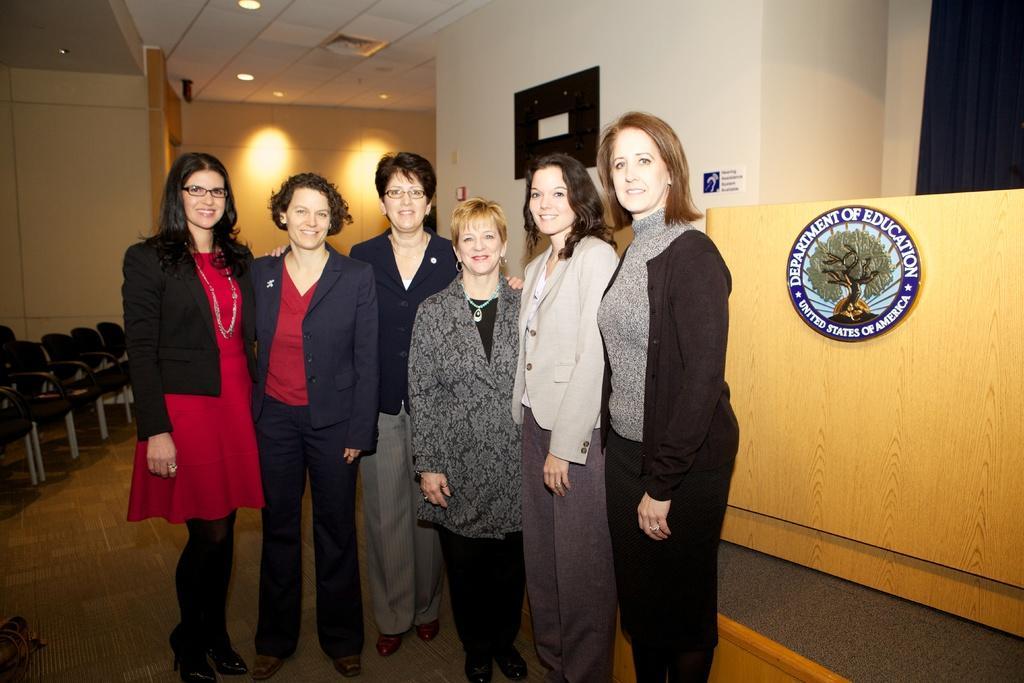Describe this image in one or two sentences. In this image we can see a group of women standing on the floor. We can also see some chairs, lights, a logo with some text on a wall and a roof with some ceiling lights. 